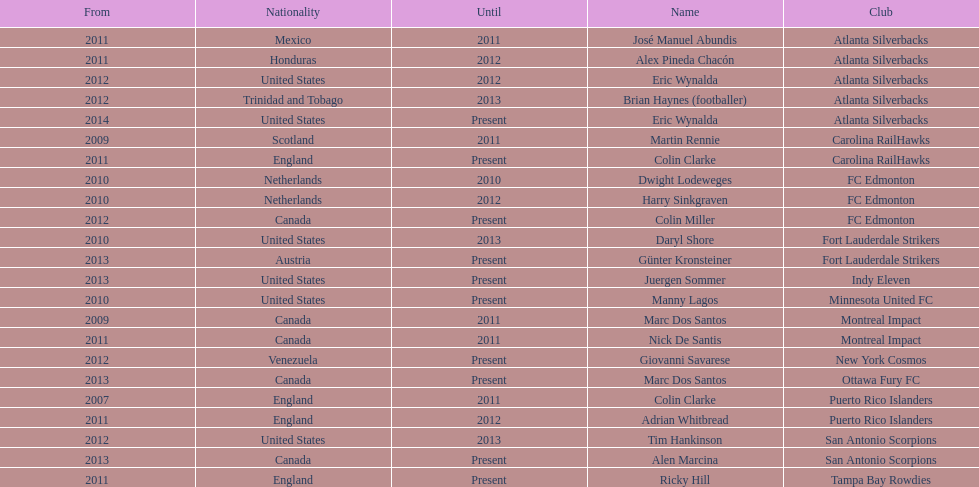What same country did marc dos santos coach as colin miller? Canada. 